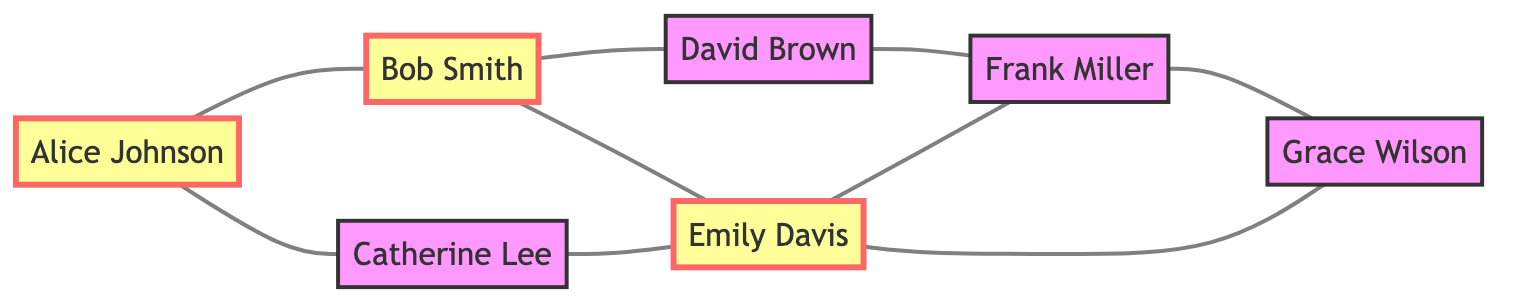What is the total number of nodes in the graph? By counting the nodes listed in the data, we identify that there are 7 nodes: Alice Johnson, Bob Smith, Catherine Lee, David Brown, Emily Davis, Frank Miller, and Grace Wilson.
Answer: 7 Which nodes are directly connected to Emily Davis? Looking at the edges connected to Emily Davis, we see that she is connected to Bob Smith, Catherine Lee, Frank Miller, and Grace Wilson.
Answer: Bob Smith, Catherine Lee, Frank Miller, Grace Wilson How many edges are there in total? By counting the edges provided in the data, we find that there are 8 unique edges connecting the nodes.
Answer: 8 Who is the only user connected to both Bob Smith and Frank Miller? By analyzing the connections, Emily Davis is the only node that has edges connecting to both Bob Smith and Frank Miller.
Answer: Emily Davis Identify the influencer(s) in the graph. From the node definitions, we can see that Alice Johnson, Bob Smith, and Emily Davis are marked as influencers in the diagram.
Answer: Alice Johnson, Bob Smith, Emily Davis Which node has the highest degree of connection? By calculating the degrees of each node, we find that Emily Davis is connected to four nodes (Bob Smith, Catherine Lee, Frank Miller, Grace Wilson), which is the highest in the graph.
Answer: Emily Davis How many connections does Frank Miller have? By examining the edges, Frank Miller is connected to David Brown, Emily Davis, and Grace Wilson, totaling three connections.
Answer: 3 What type of graph is this? This graph is an undirected graph, which means that the connections between nodes do not have a directed flow and can be traversed in both directions.
Answer: Undirected Graph Explain the relationship between Alice Johnson and Catherine Lee. There is a direct edge connecting Alice Johnson to Catherine Lee, indicating that they have a direct relationship in the network.
Answer: Direct relationship 